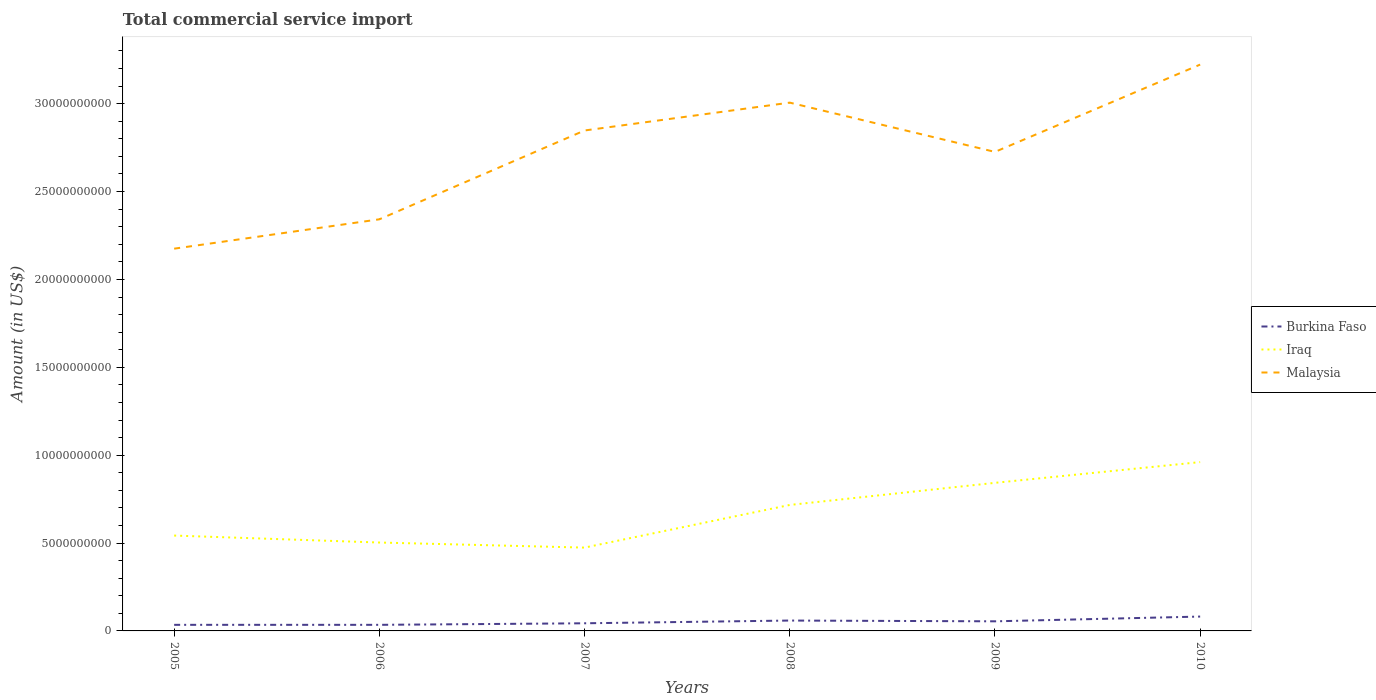How many different coloured lines are there?
Your response must be concise. 3. Does the line corresponding to Iraq intersect with the line corresponding to Malaysia?
Your answer should be very brief. No. Across all years, what is the maximum total commercial service import in Burkina Faso?
Offer a very short reply. 3.46e+08. In which year was the total commercial service import in Burkina Faso maximum?
Provide a succinct answer. 2005. What is the total total commercial service import in Burkina Faso in the graph?
Ensure brevity in your answer.  -4.71e+08. What is the difference between the highest and the second highest total commercial service import in Iraq?
Give a very brief answer. 4.87e+09. What is the difference between the highest and the lowest total commercial service import in Iraq?
Provide a short and direct response. 3. Is the total commercial service import in Malaysia strictly greater than the total commercial service import in Burkina Faso over the years?
Offer a very short reply. No. How many lines are there?
Make the answer very short. 3. How many years are there in the graph?
Make the answer very short. 6. What is the difference between two consecutive major ticks on the Y-axis?
Make the answer very short. 5.00e+09. Are the values on the major ticks of Y-axis written in scientific E-notation?
Offer a terse response. No. Where does the legend appear in the graph?
Offer a very short reply. Center right. How are the legend labels stacked?
Your answer should be compact. Vertical. What is the title of the graph?
Offer a very short reply. Total commercial service import. What is the label or title of the X-axis?
Your response must be concise. Years. What is the label or title of the Y-axis?
Offer a terse response. Amount (in US$). What is the Amount (in US$) of Burkina Faso in 2005?
Your answer should be compact. 3.46e+08. What is the Amount (in US$) of Iraq in 2005?
Make the answer very short. 5.43e+09. What is the Amount (in US$) in Malaysia in 2005?
Your response must be concise. 2.18e+1. What is the Amount (in US$) in Burkina Faso in 2006?
Provide a short and direct response. 3.46e+08. What is the Amount (in US$) in Iraq in 2006?
Make the answer very short. 5.03e+09. What is the Amount (in US$) in Malaysia in 2006?
Your answer should be very brief. 2.34e+1. What is the Amount (in US$) of Burkina Faso in 2007?
Give a very brief answer. 4.35e+08. What is the Amount (in US$) in Iraq in 2007?
Your answer should be very brief. 4.74e+09. What is the Amount (in US$) in Malaysia in 2007?
Your answer should be compact. 2.85e+1. What is the Amount (in US$) of Burkina Faso in 2008?
Your response must be concise. 5.90e+08. What is the Amount (in US$) of Iraq in 2008?
Your response must be concise. 7.17e+09. What is the Amount (in US$) of Malaysia in 2008?
Provide a short and direct response. 3.01e+1. What is the Amount (in US$) of Burkina Faso in 2009?
Your answer should be compact. 5.46e+08. What is the Amount (in US$) of Iraq in 2009?
Ensure brevity in your answer.  8.43e+09. What is the Amount (in US$) of Malaysia in 2009?
Keep it short and to the point. 2.73e+1. What is the Amount (in US$) in Burkina Faso in 2010?
Keep it short and to the point. 8.17e+08. What is the Amount (in US$) of Iraq in 2010?
Offer a terse response. 9.61e+09. What is the Amount (in US$) of Malaysia in 2010?
Provide a short and direct response. 3.22e+1. Across all years, what is the maximum Amount (in US$) in Burkina Faso?
Give a very brief answer. 8.17e+08. Across all years, what is the maximum Amount (in US$) in Iraq?
Your answer should be very brief. 9.61e+09. Across all years, what is the maximum Amount (in US$) of Malaysia?
Ensure brevity in your answer.  3.22e+1. Across all years, what is the minimum Amount (in US$) in Burkina Faso?
Offer a very short reply. 3.46e+08. Across all years, what is the minimum Amount (in US$) in Iraq?
Make the answer very short. 4.74e+09. Across all years, what is the minimum Amount (in US$) of Malaysia?
Offer a very short reply. 2.18e+1. What is the total Amount (in US$) of Burkina Faso in the graph?
Your answer should be compact. 3.08e+09. What is the total Amount (in US$) in Iraq in the graph?
Give a very brief answer. 4.04e+1. What is the total Amount (in US$) of Malaysia in the graph?
Your answer should be very brief. 1.63e+11. What is the difference between the Amount (in US$) in Burkina Faso in 2005 and that in 2006?
Offer a terse response. -1.38e+05. What is the difference between the Amount (in US$) in Iraq in 2005 and that in 2006?
Offer a terse response. 3.96e+08. What is the difference between the Amount (in US$) in Malaysia in 2005 and that in 2006?
Keep it short and to the point. -1.67e+09. What is the difference between the Amount (in US$) in Burkina Faso in 2005 and that in 2007?
Provide a succinct answer. -8.83e+07. What is the difference between the Amount (in US$) in Iraq in 2005 and that in 2007?
Give a very brief answer. 6.85e+08. What is the difference between the Amount (in US$) of Malaysia in 2005 and that in 2007?
Ensure brevity in your answer.  -6.72e+09. What is the difference between the Amount (in US$) in Burkina Faso in 2005 and that in 2008?
Provide a short and direct response. -2.44e+08. What is the difference between the Amount (in US$) of Iraq in 2005 and that in 2008?
Give a very brief answer. -1.74e+09. What is the difference between the Amount (in US$) of Malaysia in 2005 and that in 2008?
Provide a succinct answer. -8.31e+09. What is the difference between the Amount (in US$) in Burkina Faso in 2005 and that in 2009?
Offer a very short reply. -2.00e+08. What is the difference between the Amount (in US$) in Iraq in 2005 and that in 2009?
Make the answer very short. -3.00e+09. What is the difference between the Amount (in US$) in Malaysia in 2005 and that in 2009?
Make the answer very short. -5.51e+09. What is the difference between the Amount (in US$) in Burkina Faso in 2005 and that in 2010?
Give a very brief answer. -4.71e+08. What is the difference between the Amount (in US$) of Iraq in 2005 and that in 2010?
Provide a short and direct response. -4.18e+09. What is the difference between the Amount (in US$) of Malaysia in 2005 and that in 2010?
Keep it short and to the point. -1.05e+1. What is the difference between the Amount (in US$) of Burkina Faso in 2006 and that in 2007?
Your response must be concise. -8.81e+07. What is the difference between the Amount (in US$) in Iraq in 2006 and that in 2007?
Offer a terse response. 2.89e+08. What is the difference between the Amount (in US$) in Malaysia in 2006 and that in 2007?
Give a very brief answer. -5.05e+09. What is the difference between the Amount (in US$) of Burkina Faso in 2006 and that in 2008?
Give a very brief answer. -2.44e+08. What is the difference between the Amount (in US$) in Iraq in 2006 and that in 2008?
Offer a terse response. -2.14e+09. What is the difference between the Amount (in US$) of Malaysia in 2006 and that in 2008?
Offer a very short reply. -6.64e+09. What is the difference between the Amount (in US$) in Burkina Faso in 2006 and that in 2009?
Offer a terse response. -2.00e+08. What is the difference between the Amount (in US$) of Iraq in 2006 and that in 2009?
Provide a short and direct response. -3.40e+09. What is the difference between the Amount (in US$) of Malaysia in 2006 and that in 2009?
Your answer should be very brief. -3.84e+09. What is the difference between the Amount (in US$) in Burkina Faso in 2006 and that in 2010?
Provide a succinct answer. -4.71e+08. What is the difference between the Amount (in US$) of Iraq in 2006 and that in 2010?
Offer a terse response. -4.58e+09. What is the difference between the Amount (in US$) of Malaysia in 2006 and that in 2010?
Keep it short and to the point. -8.80e+09. What is the difference between the Amount (in US$) of Burkina Faso in 2007 and that in 2008?
Offer a terse response. -1.56e+08. What is the difference between the Amount (in US$) in Iraq in 2007 and that in 2008?
Your answer should be compact. -2.43e+09. What is the difference between the Amount (in US$) in Malaysia in 2007 and that in 2008?
Ensure brevity in your answer.  -1.58e+09. What is the difference between the Amount (in US$) of Burkina Faso in 2007 and that in 2009?
Offer a very short reply. -1.12e+08. What is the difference between the Amount (in US$) of Iraq in 2007 and that in 2009?
Your answer should be very brief. -3.68e+09. What is the difference between the Amount (in US$) of Malaysia in 2007 and that in 2009?
Provide a short and direct response. 1.22e+09. What is the difference between the Amount (in US$) in Burkina Faso in 2007 and that in 2010?
Keep it short and to the point. -3.82e+08. What is the difference between the Amount (in US$) of Iraq in 2007 and that in 2010?
Your answer should be compact. -4.87e+09. What is the difference between the Amount (in US$) of Malaysia in 2007 and that in 2010?
Provide a succinct answer. -3.75e+09. What is the difference between the Amount (in US$) of Burkina Faso in 2008 and that in 2009?
Keep it short and to the point. 4.38e+07. What is the difference between the Amount (in US$) of Iraq in 2008 and that in 2009?
Make the answer very short. -1.26e+09. What is the difference between the Amount (in US$) in Malaysia in 2008 and that in 2009?
Your answer should be compact. 2.80e+09. What is the difference between the Amount (in US$) of Burkina Faso in 2008 and that in 2010?
Provide a short and direct response. -2.27e+08. What is the difference between the Amount (in US$) of Iraq in 2008 and that in 2010?
Keep it short and to the point. -2.44e+09. What is the difference between the Amount (in US$) in Malaysia in 2008 and that in 2010?
Give a very brief answer. -2.16e+09. What is the difference between the Amount (in US$) of Burkina Faso in 2009 and that in 2010?
Make the answer very short. -2.71e+08. What is the difference between the Amount (in US$) in Iraq in 2009 and that in 2010?
Your answer should be compact. -1.18e+09. What is the difference between the Amount (in US$) of Malaysia in 2009 and that in 2010?
Offer a terse response. -4.97e+09. What is the difference between the Amount (in US$) in Burkina Faso in 2005 and the Amount (in US$) in Iraq in 2006?
Offer a terse response. -4.68e+09. What is the difference between the Amount (in US$) of Burkina Faso in 2005 and the Amount (in US$) of Malaysia in 2006?
Your answer should be compact. -2.31e+1. What is the difference between the Amount (in US$) in Iraq in 2005 and the Amount (in US$) in Malaysia in 2006?
Provide a short and direct response. -1.80e+1. What is the difference between the Amount (in US$) in Burkina Faso in 2005 and the Amount (in US$) in Iraq in 2007?
Your response must be concise. -4.39e+09. What is the difference between the Amount (in US$) of Burkina Faso in 2005 and the Amount (in US$) of Malaysia in 2007?
Give a very brief answer. -2.81e+1. What is the difference between the Amount (in US$) of Iraq in 2005 and the Amount (in US$) of Malaysia in 2007?
Your answer should be compact. -2.30e+1. What is the difference between the Amount (in US$) of Burkina Faso in 2005 and the Amount (in US$) of Iraq in 2008?
Provide a short and direct response. -6.82e+09. What is the difference between the Amount (in US$) in Burkina Faso in 2005 and the Amount (in US$) in Malaysia in 2008?
Your answer should be compact. -2.97e+1. What is the difference between the Amount (in US$) in Iraq in 2005 and the Amount (in US$) in Malaysia in 2008?
Offer a terse response. -2.46e+1. What is the difference between the Amount (in US$) in Burkina Faso in 2005 and the Amount (in US$) in Iraq in 2009?
Make the answer very short. -8.08e+09. What is the difference between the Amount (in US$) of Burkina Faso in 2005 and the Amount (in US$) of Malaysia in 2009?
Offer a terse response. -2.69e+1. What is the difference between the Amount (in US$) of Iraq in 2005 and the Amount (in US$) of Malaysia in 2009?
Offer a very short reply. -2.18e+1. What is the difference between the Amount (in US$) of Burkina Faso in 2005 and the Amount (in US$) of Iraq in 2010?
Make the answer very short. -9.26e+09. What is the difference between the Amount (in US$) in Burkina Faso in 2005 and the Amount (in US$) in Malaysia in 2010?
Make the answer very short. -3.19e+1. What is the difference between the Amount (in US$) of Iraq in 2005 and the Amount (in US$) of Malaysia in 2010?
Your answer should be compact. -2.68e+1. What is the difference between the Amount (in US$) in Burkina Faso in 2006 and the Amount (in US$) in Iraq in 2007?
Offer a terse response. -4.39e+09. What is the difference between the Amount (in US$) of Burkina Faso in 2006 and the Amount (in US$) of Malaysia in 2007?
Provide a short and direct response. -2.81e+1. What is the difference between the Amount (in US$) of Iraq in 2006 and the Amount (in US$) of Malaysia in 2007?
Your response must be concise. -2.34e+1. What is the difference between the Amount (in US$) in Burkina Faso in 2006 and the Amount (in US$) in Iraq in 2008?
Give a very brief answer. -6.82e+09. What is the difference between the Amount (in US$) of Burkina Faso in 2006 and the Amount (in US$) of Malaysia in 2008?
Keep it short and to the point. -2.97e+1. What is the difference between the Amount (in US$) in Iraq in 2006 and the Amount (in US$) in Malaysia in 2008?
Offer a very short reply. -2.50e+1. What is the difference between the Amount (in US$) of Burkina Faso in 2006 and the Amount (in US$) of Iraq in 2009?
Offer a very short reply. -8.08e+09. What is the difference between the Amount (in US$) of Burkina Faso in 2006 and the Amount (in US$) of Malaysia in 2009?
Provide a short and direct response. -2.69e+1. What is the difference between the Amount (in US$) of Iraq in 2006 and the Amount (in US$) of Malaysia in 2009?
Offer a terse response. -2.22e+1. What is the difference between the Amount (in US$) in Burkina Faso in 2006 and the Amount (in US$) in Iraq in 2010?
Keep it short and to the point. -9.26e+09. What is the difference between the Amount (in US$) in Burkina Faso in 2006 and the Amount (in US$) in Malaysia in 2010?
Your answer should be very brief. -3.19e+1. What is the difference between the Amount (in US$) in Iraq in 2006 and the Amount (in US$) in Malaysia in 2010?
Give a very brief answer. -2.72e+1. What is the difference between the Amount (in US$) of Burkina Faso in 2007 and the Amount (in US$) of Iraq in 2008?
Your answer should be very brief. -6.73e+09. What is the difference between the Amount (in US$) in Burkina Faso in 2007 and the Amount (in US$) in Malaysia in 2008?
Offer a very short reply. -2.96e+1. What is the difference between the Amount (in US$) in Iraq in 2007 and the Amount (in US$) in Malaysia in 2008?
Your answer should be very brief. -2.53e+1. What is the difference between the Amount (in US$) in Burkina Faso in 2007 and the Amount (in US$) in Iraq in 2009?
Your response must be concise. -7.99e+09. What is the difference between the Amount (in US$) in Burkina Faso in 2007 and the Amount (in US$) in Malaysia in 2009?
Your answer should be very brief. -2.68e+1. What is the difference between the Amount (in US$) in Iraq in 2007 and the Amount (in US$) in Malaysia in 2009?
Your answer should be very brief. -2.25e+1. What is the difference between the Amount (in US$) of Burkina Faso in 2007 and the Amount (in US$) of Iraq in 2010?
Keep it short and to the point. -9.17e+09. What is the difference between the Amount (in US$) of Burkina Faso in 2007 and the Amount (in US$) of Malaysia in 2010?
Make the answer very short. -3.18e+1. What is the difference between the Amount (in US$) of Iraq in 2007 and the Amount (in US$) of Malaysia in 2010?
Provide a short and direct response. -2.75e+1. What is the difference between the Amount (in US$) in Burkina Faso in 2008 and the Amount (in US$) in Iraq in 2009?
Ensure brevity in your answer.  -7.84e+09. What is the difference between the Amount (in US$) in Burkina Faso in 2008 and the Amount (in US$) in Malaysia in 2009?
Your answer should be compact. -2.67e+1. What is the difference between the Amount (in US$) in Iraq in 2008 and the Amount (in US$) in Malaysia in 2009?
Give a very brief answer. -2.01e+1. What is the difference between the Amount (in US$) in Burkina Faso in 2008 and the Amount (in US$) in Iraq in 2010?
Your response must be concise. -9.02e+09. What is the difference between the Amount (in US$) of Burkina Faso in 2008 and the Amount (in US$) of Malaysia in 2010?
Provide a succinct answer. -3.16e+1. What is the difference between the Amount (in US$) in Iraq in 2008 and the Amount (in US$) in Malaysia in 2010?
Keep it short and to the point. -2.51e+1. What is the difference between the Amount (in US$) in Burkina Faso in 2009 and the Amount (in US$) in Iraq in 2010?
Your answer should be very brief. -9.06e+09. What is the difference between the Amount (in US$) in Burkina Faso in 2009 and the Amount (in US$) in Malaysia in 2010?
Offer a terse response. -3.17e+1. What is the difference between the Amount (in US$) of Iraq in 2009 and the Amount (in US$) of Malaysia in 2010?
Provide a short and direct response. -2.38e+1. What is the average Amount (in US$) in Burkina Faso per year?
Provide a short and direct response. 5.13e+08. What is the average Amount (in US$) of Iraq per year?
Offer a terse response. 6.73e+09. What is the average Amount (in US$) in Malaysia per year?
Your answer should be compact. 2.72e+1. In the year 2005, what is the difference between the Amount (in US$) of Burkina Faso and Amount (in US$) of Iraq?
Provide a short and direct response. -5.08e+09. In the year 2005, what is the difference between the Amount (in US$) of Burkina Faso and Amount (in US$) of Malaysia?
Provide a succinct answer. -2.14e+1. In the year 2005, what is the difference between the Amount (in US$) of Iraq and Amount (in US$) of Malaysia?
Your answer should be very brief. -1.63e+1. In the year 2006, what is the difference between the Amount (in US$) in Burkina Faso and Amount (in US$) in Iraq?
Your response must be concise. -4.68e+09. In the year 2006, what is the difference between the Amount (in US$) in Burkina Faso and Amount (in US$) in Malaysia?
Provide a succinct answer. -2.31e+1. In the year 2006, what is the difference between the Amount (in US$) of Iraq and Amount (in US$) of Malaysia?
Offer a terse response. -1.84e+1. In the year 2007, what is the difference between the Amount (in US$) of Burkina Faso and Amount (in US$) of Iraq?
Keep it short and to the point. -4.31e+09. In the year 2007, what is the difference between the Amount (in US$) in Burkina Faso and Amount (in US$) in Malaysia?
Ensure brevity in your answer.  -2.80e+1. In the year 2007, what is the difference between the Amount (in US$) in Iraq and Amount (in US$) in Malaysia?
Your answer should be very brief. -2.37e+1. In the year 2008, what is the difference between the Amount (in US$) in Burkina Faso and Amount (in US$) in Iraq?
Offer a very short reply. -6.58e+09. In the year 2008, what is the difference between the Amount (in US$) in Burkina Faso and Amount (in US$) in Malaysia?
Make the answer very short. -2.95e+1. In the year 2008, what is the difference between the Amount (in US$) of Iraq and Amount (in US$) of Malaysia?
Your answer should be very brief. -2.29e+1. In the year 2009, what is the difference between the Amount (in US$) in Burkina Faso and Amount (in US$) in Iraq?
Keep it short and to the point. -7.88e+09. In the year 2009, what is the difference between the Amount (in US$) in Burkina Faso and Amount (in US$) in Malaysia?
Give a very brief answer. -2.67e+1. In the year 2009, what is the difference between the Amount (in US$) of Iraq and Amount (in US$) of Malaysia?
Provide a short and direct response. -1.88e+1. In the year 2010, what is the difference between the Amount (in US$) of Burkina Faso and Amount (in US$) of Iraq?
Make the answer very short. -8.79e+09. In the year 2010, what is the difference between the Amount (in US$) in Burkina Faso and Amount (in US$) in Malaysia?
Keep it short and to the point. -3.14e+1. In the year 2010, what is the difference between the Amount (in US$) of Iraq and Amount (in US$) of Malaysia?
Provide a succinct answer. -2.26e+1. What is the ratio of the Amount (in US$) in Iraq in 2005 to that in 2006?
Provide a short and direct response. 1.08. What is the ratio of the Amount (in US$) in Malaysia in 2005 to that in 2006?
Your answer should be very brief. 0.93. What is the ratio of the Amount (in US$) of Burkina Faso in 2005 to that in 2007?
Keep it short and to the point. 0.8. What is the ratio of the Amount (in US$) of Iraq in 2005 to that in 2007?
Your answer should be compact. 1.14. What is the ratio of the Amount (in US$) of Malaysia in 2005 to that in 2007?
Keep it short and to the point. 0.76. What is the ratio of the Amount (in US$) in Burkina Faso in 2005 to that in 2008?
Your answer should be compact. 0.59. What is the ratio of the Amount (in US$) in Iraq in 2005 to that in 2008?
Keep it short and to the point. 0.76. What is the ratio of the Amount (in US$) in Malaysia in 2005 to that in 2008?
Your response must be concise. 0.72. What is the ratio of the Amount (in US$) in Burkina Faso in 2005 to that in 2009?
Offer a terse response. 0.63. What is the ratio of the Amount (in US$) in Iraq in 2005 to that in 2009?
Provide a short and direct response. 0.64. What is the ratio of the Amount (in US$) of Malaysia in 2005 to that in 2009?
Make the answer very short. 0.8. What is the ratio of the Amount (in US$) of Burkina Faso in 2005 to that in 2010?
Offer a terse response. 0.42. What is the ratio of the Amount (in US$) of Iraq in 2005 to that in 2010?
Ensure brevity in your answer.  0.56. What is the ratio of the Amount (in US$) of Malaysia in 2005 to that in 2010?
Offer a terse response. 0.68. What is the ratio of the Amount (in US$) in Burkina Faso in 2006 to that in 2007?
Your answer should be very brief. 0.8. What is the ratio of the Amount (in US$) in Iraq in 2006 to that in 2007?
Give a very brief answer. 1.06. What is the ratio of the Amount (in US$) of Malaysia in 2006 to that in 2007?
Offer a very short reply. 0.82. What is the ratio of the Amount (in US$) in Burkina Faso in 2006 to that in 2008?
Provide a short and direct response. 0.59. What is the ratio of the Amount (in US$) of Iraq in 2006 to that in 2008?
Your answer should be compact. 0.7. What is the ratio of the Amount (in US$) in Malaysia in 2006 to that in 2008?
Provide a short and direct response. 0.78. What is the ratio of the Amount (in US$) of Burkina Faso in 2006 to that in 2009?
Your answer should be very brief. 0.63. What is the ratio of the Amount (in US$) of Iraq in 2006 to that in 2009?
Give a very brief answer. 0.6. What is the ratio of the Amount (in US$) in Malaysia in 2006 to that in 2009?
Ensure brevity in your answer.  0.86. What is the ratio of the Amount (in US$) in Burkina Faso in 2006 to that in 2010?
Offer a terse response. 0.42. What is the ratio of the Amount (in US$) of Iraq in 2006 to that in 2010?
Give a very brief answer. 0.52. What is the ratio of the Amount (in US$) in Malaysia in 2006 to that in 2010?
Give a very brief answer. 0.73. What is the ratio of the Amount (in US$) in Burkina Faso in 2007 to that in 2008?
Keep it short and to the point. 0.74. What is the ratio of the Amount (in US$) in Iraq in 2007 to that in 2008?
Keep it short and to the point. 0.66. What is the ratio of the Amount (in US$) of Malaysia in 2007 to that in 2008?
Offer a terse response. 0.95. What is the ratio of the Amount (in US$) of Burkina Faso in 2007 to that in 2009?
Your answer should be compact. 0.8. What is the ratio of the Amount (in US$) of Iraq in 2007 to that in 2009?
Offer a terse response. 0.56. What is the ratio of the Amount (in US$) of Malaysia in 2007 to that in 2009?
Make the answer very short. 1.04. What is the ratio of the Amount (in US$) of Burkina Faso in 2007 to that in 2010?
Your response must be concise. 0.53. What is the ratio of the Amount (in US$) in Iraq in 2007 to that in 2010?
Offer a terse response. 0.49. What is the ratio of the Amount (in US$) of Malaysia in 2007 to that in 2010?
Offer a very short reply. 0.88. What is the ratio of the Amount (in US$) in Burkina Faso in 2008 to that in 2009?
Offer a very short reply. 1.08. What is the ratio of the Amount (in US$) in Iraq in 2008 to that in 2009?
Provide a succinct answer. 0.85. What is the ratio of the Amount (in US$) in Malaysia in 2008 to that in 2009?
Your answer should be very brief. 1.1. What is the ratio of the Amount (in US$) of Burkina Faso in 2008 to that in 2010?
Ensure brevity in your answer.  0.72. What is the ratio of the Amount (in US$) in Iraq in 2008 to that in 2010?
Offer a terse response. 0.75. What is the ratio of the Amount (in US$) in Malaysia in 2008 to that in 2010?
Your answer should be compact. 0.93. What is the ratio of the Amount (in US$) in Burkina Faso in 2009 to that in 2010?
Your answer should be very brief. 0.67. What is the ratio of the Amount (in US$) of Iraq in 2009 to that in 2010?
Provide a succinct answer. 0.88. What is the ratio of the Amount (in US$) in Malaysia in 2009 to that in 2010?
Offer a very short reply. 0.85. What is the difference between the highest and the second highest Amount (in US$) of Burkina Faso?
Your response must be concise. 2.27e+08. What is the difference between the highest and the second highest Amount (in US$) in Iraq?
Provide a short and direct response. 1.18e+09. What is the difference between the highest and the second highest Amount (in US$) in Malaysia?
Give a very brief answer. 2.16e+09. What is the difference between the highest and the lowest Amount (in US$) of Burkina Faso?
Give a very brief answer. 4.71e+08. What is the difference between the highest and the lowest Amount (in US$) in Iraq?
Provide a succinct answer. 4.87e+09. What is the difference between the highest and the lowest Amount (in US$) in Malaysia?
Your answer should be compact. 1.05e+1. 